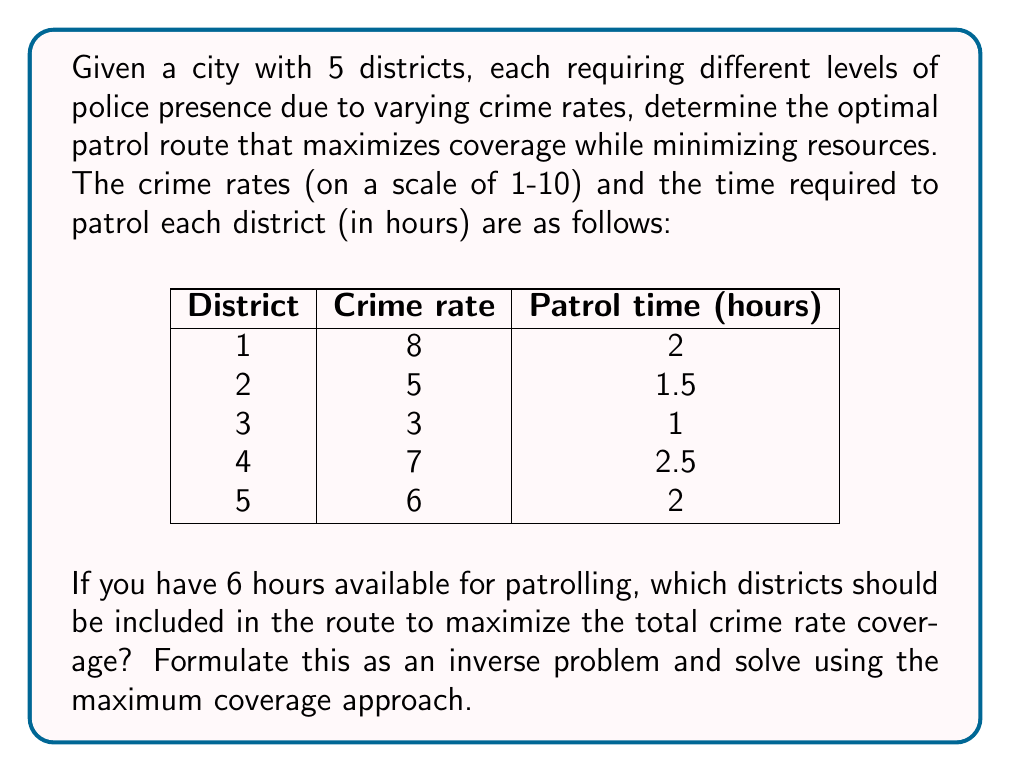Help me with this question. To solve this inverse problem, we need to maximize the coverage of crime rates within the given time constraint. Let's approach this step-by-step:

1) First, let's define our variables:
   Let $x_i$ be a binary variable where $x_i = 1$ if district $i$ is included in the route, and 0 otherwise.

2) Our objective function is to maximize the total crime rate covered:
   $$ \text{Maximize } Z = 8x_1 + 5x_2 + 3x_3 + 7x_4 + 6x_5 $$

3) The constraint is the total patrol time, which must not exceed 6 hours:
   $$ 2x_1 + 1.5x_2 + x_3 + 2.5x_4 + 2x_5 \leq 6 $$

4) This is a 0-1 knapsack problem, which is a type of inverse problem. We can solve it using dynamic programming or a greedy approach. Given the small number of districts, we can use a greedy approach here.

5) Calculate the efficiency (crime rate / patrol time) for each district:
   District 1: 8/2 = 4
   District 2: 5/1.5 ≈ 3.33
   District 3: 3/1 = 3
   District 4: 7/2.5 = 2.8
   District 5: 6/2 = 3

6) Sort the districts by efficiency (highest to lowest):
   1, 2, 5, 3, 4

7) Start selecting districts in this order until we run out of time:
   District 1: 2 hours used, 4 hours left
   District 2: 1.5 hours used, 2.5 hours left
   District 5: 2 hours used, 0.5 hours left

8) We can't fit any more districts in the remaining 0.5 hours.

Therefore, the optimal route includes Districts 1, 2, and 5.
Answer: Districts 1, 2, and 5 